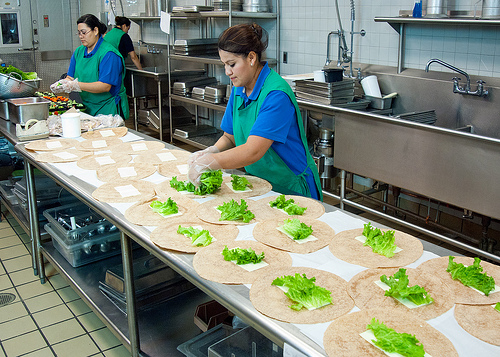Please provide the bounding box coordinate of the region this sentence describes: the apron is green. [0.43, 0.29, 0.71, 0.65]. The coordinates include the entire area of the green apron worn by the woman in the foreground, effectively capturing its extent. 